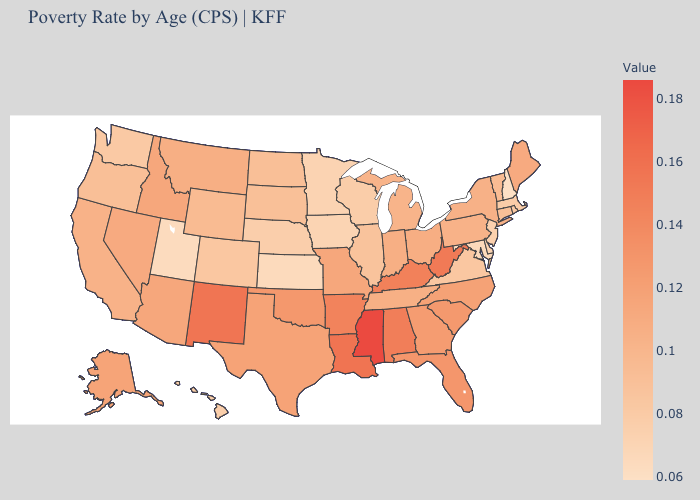Does Hawaii have a higher value than Vermont?
Write a very short answer. No. Which states have the lowest value in the USA?
Short answer required. New Hampshire. Does Montana have a lower value than New Mexico?
Write a very short answer. Yes. 